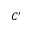Convert formula to latex. <formula><loc_0><loc_0><loc_500><loc_500>C ^ { \prime }</formula> 